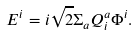<formula> <loc_0><loc_0><loc_500><loc_500>E ^ { i } = i \sqrt { 2 } \Sigma _ { a } Q ^ { a } _ { i } \Phi ^ { i } .</formula> 